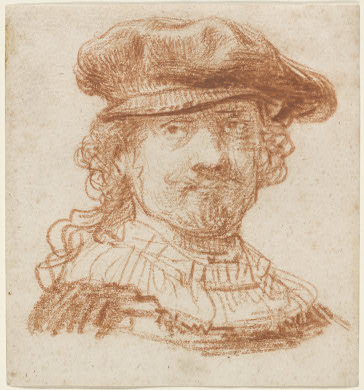This portrait is actually a magical relic. What powers does it grant to those who possess it? This portrait is indeed a magical relic. It grants the possessor the ability to traverse through time. By gazing into the eyes of the figure, the holder can choose to be transported to any moment in history. Additionally, the portrait provides the wisdom and knowledge of the Baroque period artist, allowing the possessor to see the world through the eyes of a master artist. This includes heightened senses for appreciating art, advanced artistic skills, and an innate understanding of historical contexts from the Baroque era. The relic also offers protection against malevolent spirits by emitting a calming aura, soothing any presence within its vicinity. 